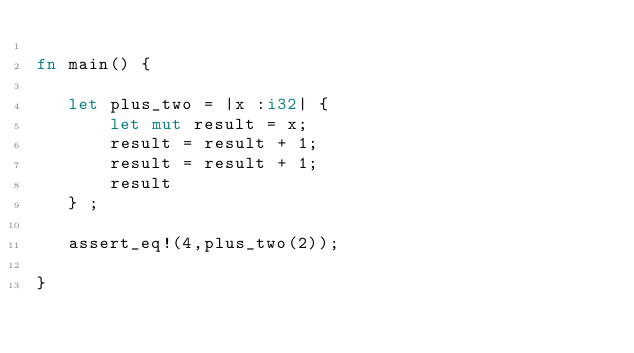Convert code to text. <code><loc_0><loc_0><loc_500><loc_500><_Rust_>
fn main() {

   let plus_two = |x :i32| {
       let mut result = x;
       result = result + 1;
       result = result + 1;
       result
   } ;

   assert_eq!(4,plus_two(2));

}</code> 